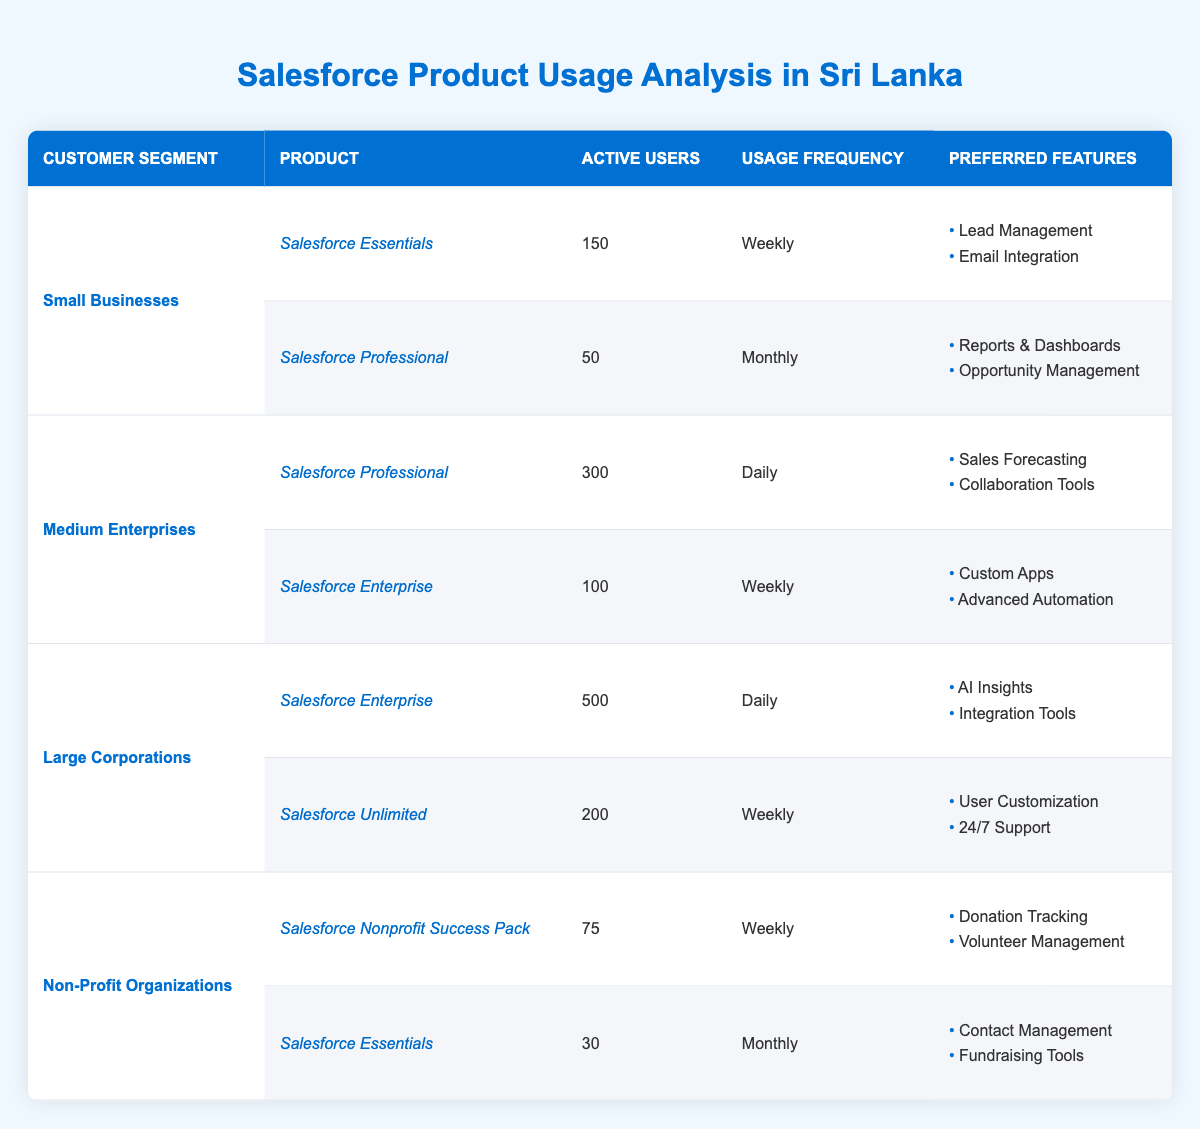What is the usage frequency of Salesforce Essentials for Small Businesses? The table lists that Salesforce Essentials has 150 active users in the Small Businesses segment, and its usage frequency is specified as "Weekly."
Answer: Weekly How many active users are there for Salesforce Professional in Medium Enterprises? The table shows that in the Medium Enterprises segment, Salesforce Professional has 300 active users.
Answer: 300 Which customer segment has the highest number of active users for Salesforce Enterprise? The Large Corporations segment has 500 active users for Salesforce Enterprise, which is the highest compared to other segments listed in the table.
Answer: Large Corporations Is Salesforce Nonprofit Success Pack used more frequently than Salesforce Essentials by Non-Profit Organizations? Both products are used by Non-Profit Organizations; Salesforce Nonprofit Success Pack has 75 active users with a "Weekly" frequency, while Salesforce Essentials has 30 active users with a "Monthly" frequency, which means Nonprofit Success Pack is indeed used more frequently.
Answer: Yes What is the total number of active users across all products for Non-Profit Organizations? For Non-Profit Organizations, Salesforce Nonprofit Success Pack has 75 active users, and Salesforce Essentials has 30 active users. The total is 75 + 30 = 105 active users.
Answer: 105 Which product has the least number of active users and what is that number? Upon examining the table, Salesforce Essentials for Non-Profit Organizations has the least number of active users, which is 30.
Answer: 30 How does the usage frequency differ among products in the Small Businesses segment? In the Small Businesses segment, Salesforce Essentials is used weekly by 150 users while Salesforce Professional is used monthly by 50 users. The difference in frequency is that one is used weekly and the other monthly.
Answer: Weekly/Monthly What are the preferred features of Salesforce Enterprise for Large Corporations? The table indicates that the preferred features of Salesforce Enterprise for Large Corporations include "AI Insights" and "Integration Tools."
Answer: AI Insights, Integration Tools How many products are actively used by Medium Enterprises, and what products are they? The table shows that Medium Enterprises actively use two products: Salesforce Professional and Salesforce Enterprise.
Answer: Two products: Salesforce Professional, Salesforce Enterprise 